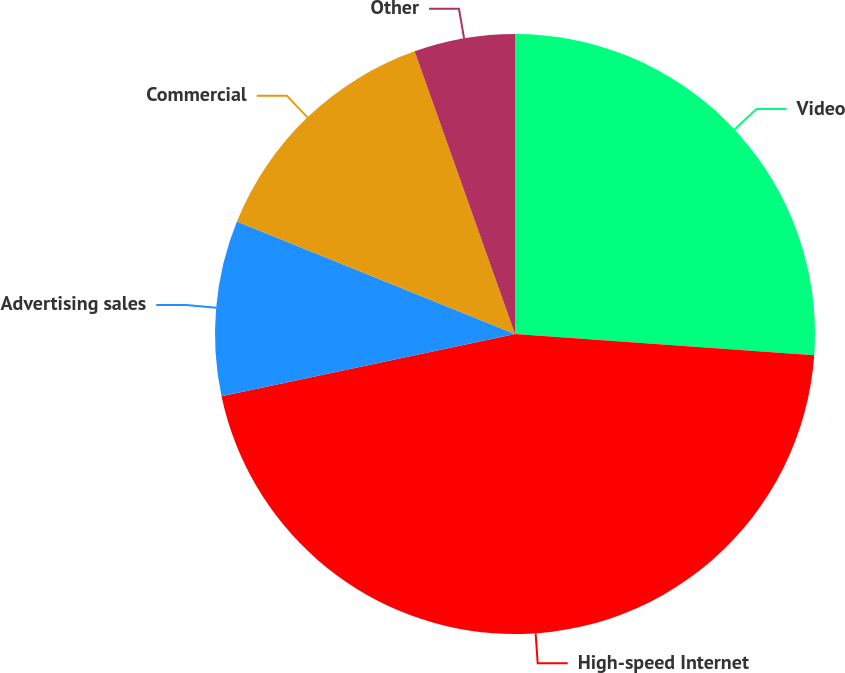Convert chart to OTSL. <chart><loc_0><loc_0><loc_500><loc_500><pie_chart><fcel>Video<fcel>High-speed Internet<fcel>Advertising sales<fcel>Commercial<fcel>Other<nl><fcel>26.13%<fcel>45.54%<fcel>9.44%<fcel>13.45%<fcel>5.43%<nl></chart> 